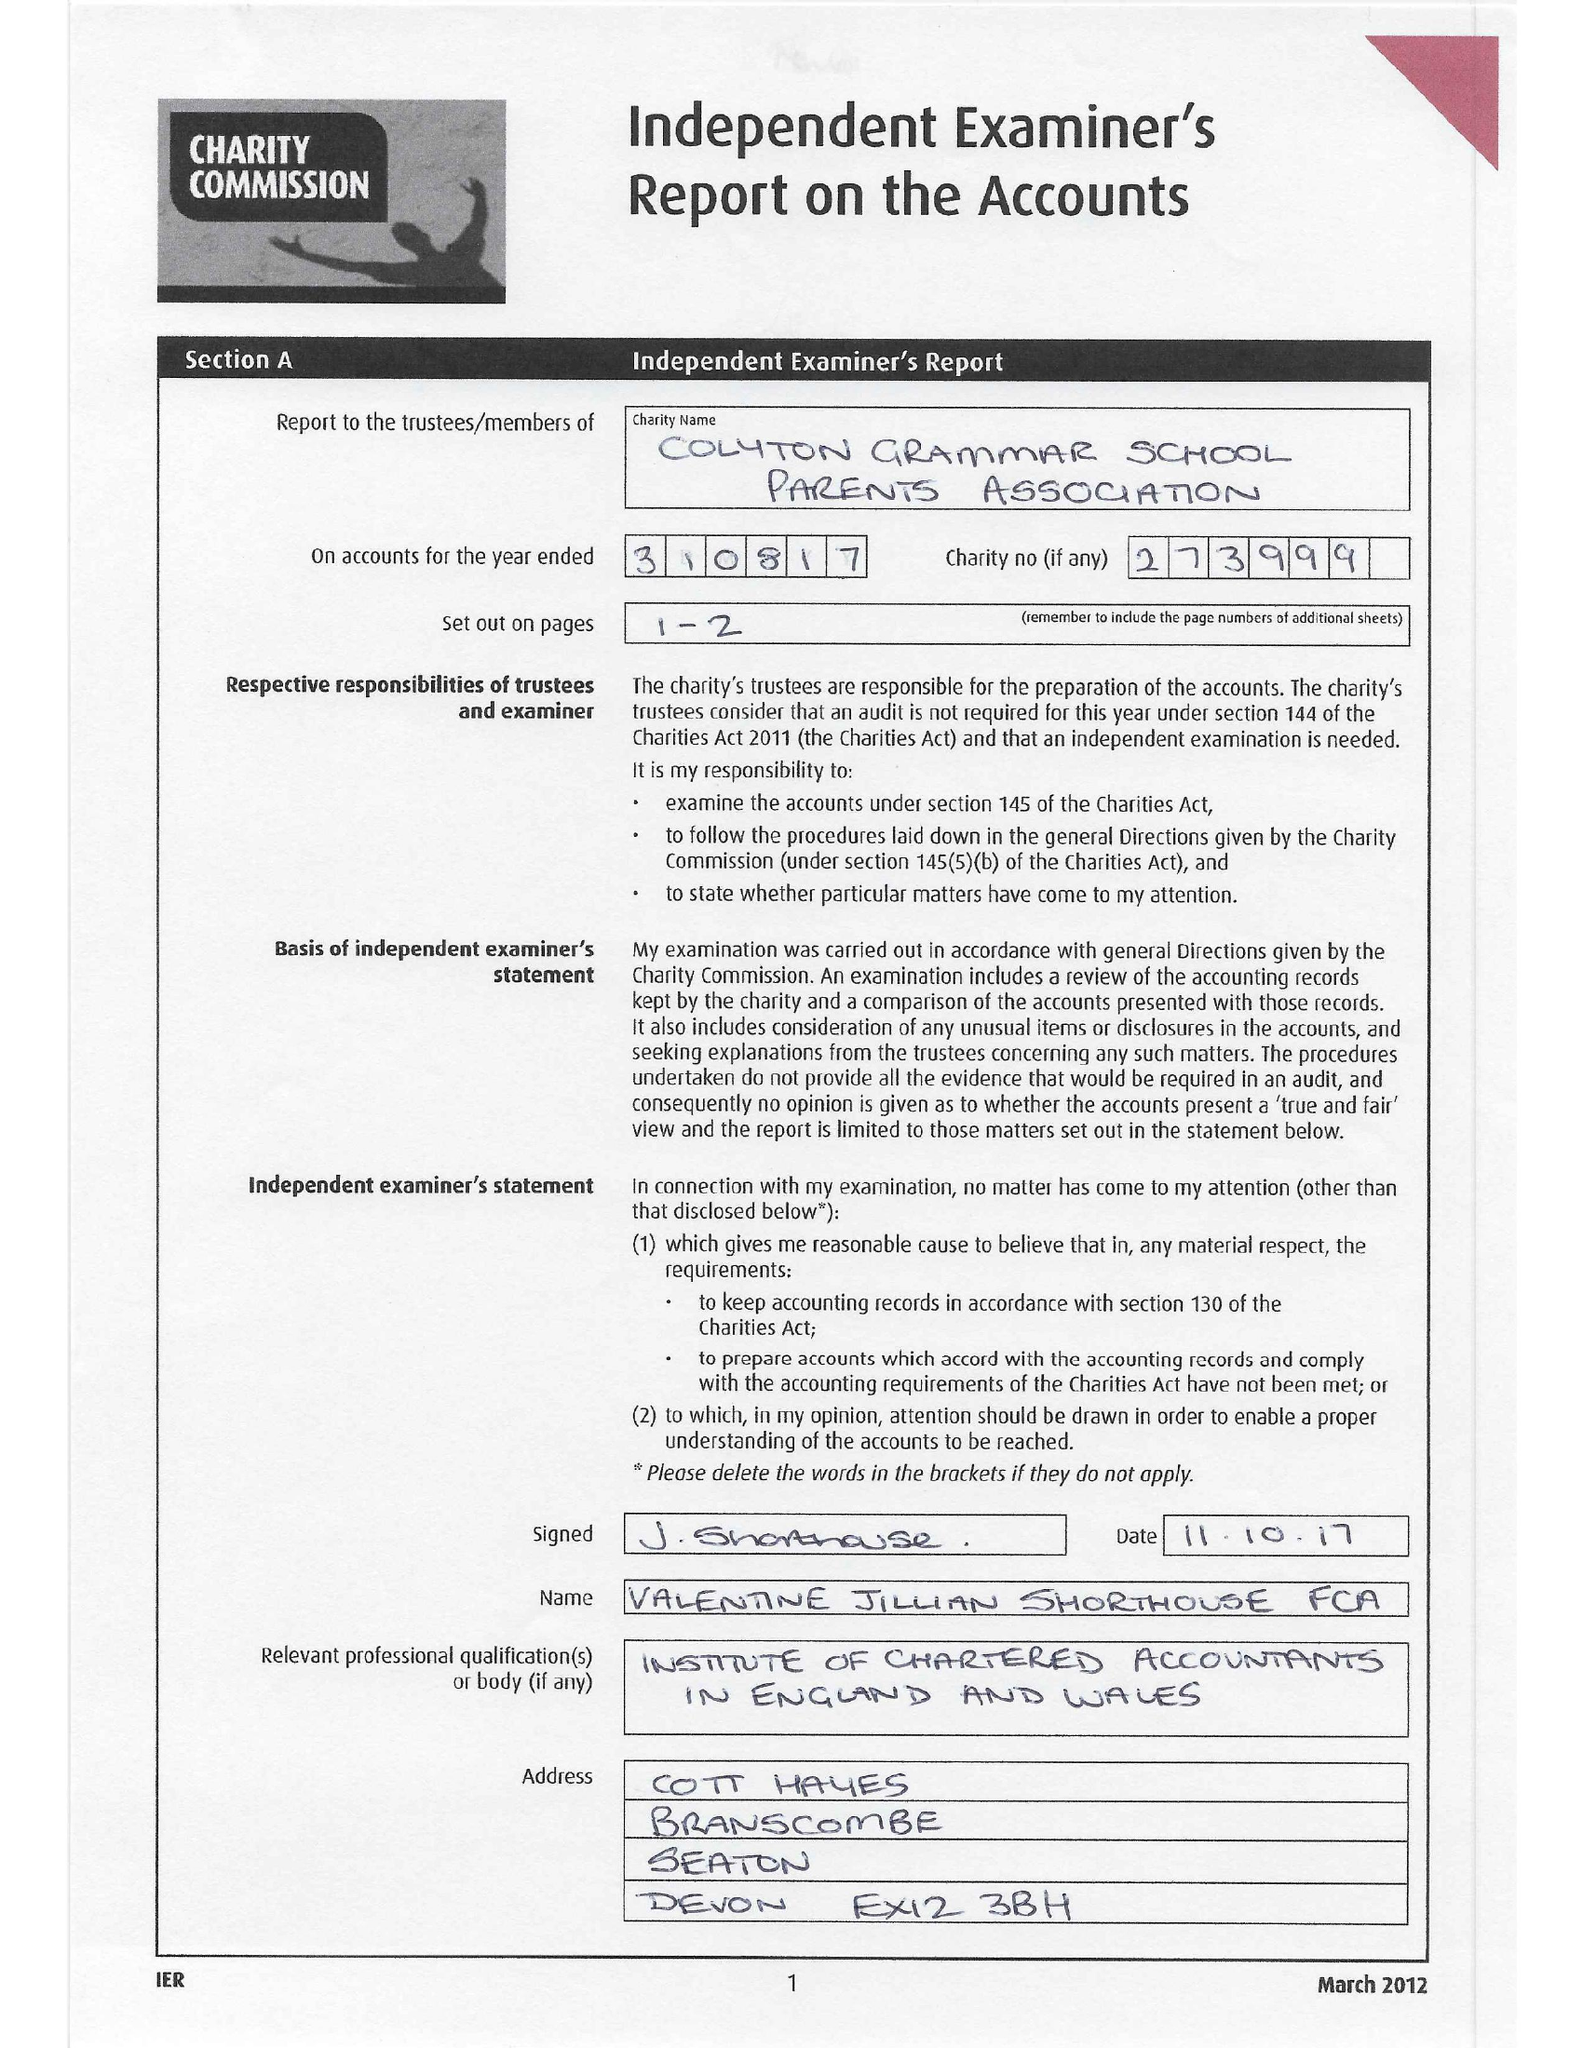What is the value for the address__post_town?
Answer the question using a single word or phrase. COLYTON 